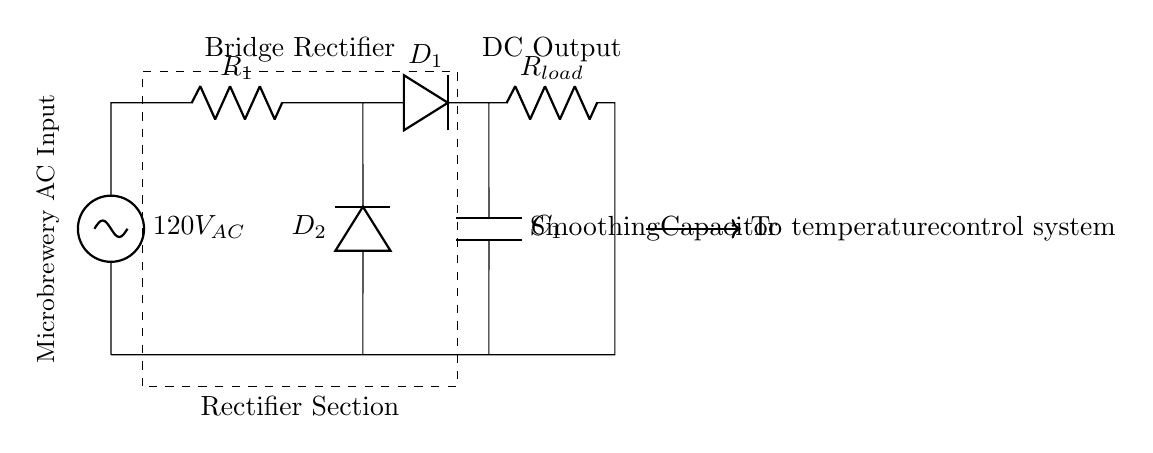What type of rectifier is used in this circuit? The circuit uses a bridge rectifier, which is indicated by the configuration of two diodes on each side connected in such a way to allow both halves of the AC input to contribute to the DC output.
Answer: Bridge rectifier What is the AC voltage supplied to the circuit? The diagram shows a voltage source labeled 120V AC, indicating the supply voltage provided to the rectifier.
Answer: 120V AC What is the purpose of the smoothing capacitor? The smoothing capacitor is used to reduce voltage ripple, which ensures a more stable DC output by charging during peaks and discharging during dips in the voltage.
Answer: Reduce voltage ripple How many diodes are present in the rectifier section? The diagram clearly shows two diodes, labeled D1 and D2, which are part of the bridge rectifier circuit.
Answer: Two diodes What is the function of the load resistor in this circuit? The load resistor, labeled R_load, represents the component that will utilize the DC output from the rectifier; it converts electrical energy into another form of energy, typically heat.
Answer: Utilize DC output What is the connection configuration of the diodes in this circuit? The diodes are arranged in a bridge configuration, allowing current to pass through in one direction during each half cycle of the AC input, thus providing continuous DC output.
Answer: Bridge configuration What component is used to filter the output voltage in this circuit? The output voltage is filtered by the smoothing capacitor, which helps to maintain a steady voltage level at the output by charging and discharging appropriately.
Answer: Smoothing capacitor 